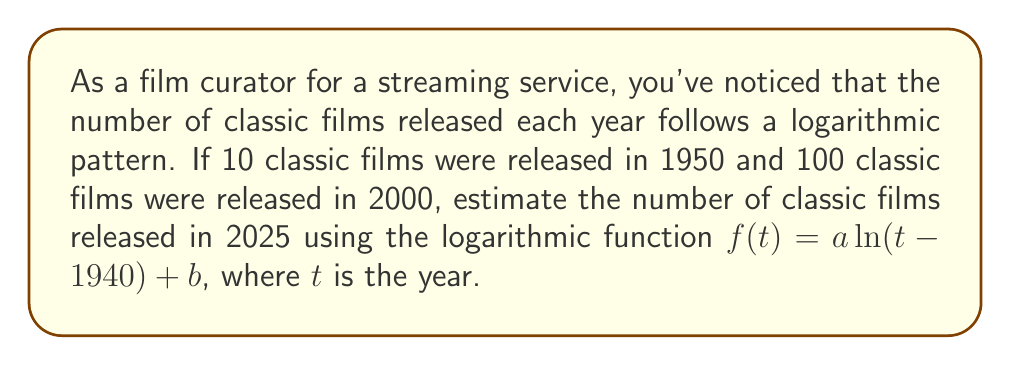Provide a solution to this math problem. 1) Let's define our logarithmic function: $f(t) = a \ln(t - 1940) + b$

2) We have two data points:
   For 1950: $f(1950) = 10$
   For 2000: $f(2000) = 100$

3) Let's substitute these into our function:
   $10 = a \ln(1950 - 1940) + b$
   $10 = a \ln(10) + b$

   $100 = a \ln(2000 - 1940) + b$
   $100 = a \ln(60) + b$

4) Subtract the first equation from the second:
   $90 = a(\ln(60) - \ln(10))$
   $90 = a \ln(6)$

5) Solve for $a$:
   $a = \frac{90}{\ln(6)} \approx 51.08$

6) Substitute this back into one of the original equations to find $b$:
   $10 = 51.08 \ln(10) + b$
   $b = 10 - 51.08 \ln(10) \approx -107.67$

7) Our function is now:
   $f(t) = 51.08 \ln(t - 1940) - 107.67$

8) To estimate the number of classic films in 2025, we substitute $t = 2025$:
   $f(2025) = 51.08 \ln(2025 - 1940) - 107.67$
   $f(2025) = 51.08 \ln(85) - 107.67$
   $f(2025) \approx 116.7$

9) Rounding to the nearest whole number, we estimate 117 classic films in 2025.
Answer: 117 classic films 